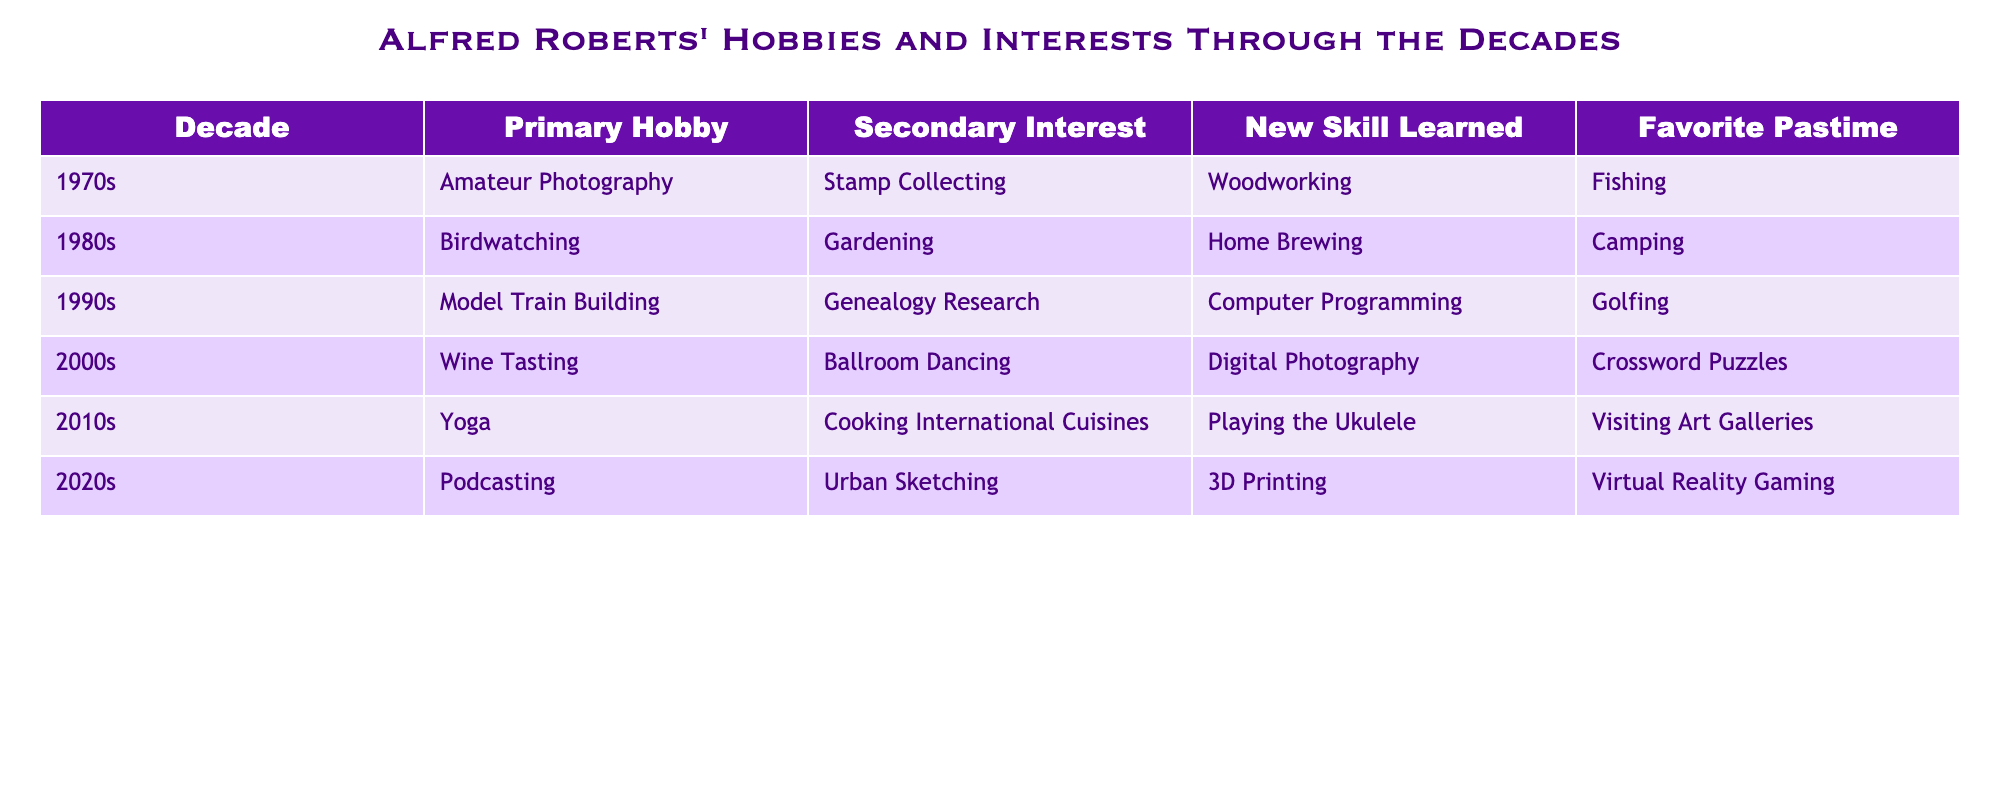What was Alfred's primary hobby in the 1990s? According to the table, the primary hobby listed for the 1990s is "Model Train Building."
Answer: Model Train Building Which decade did Alfred start practicing yoga? The table indicates that Alfred started practicing yoga in the 2010s, as it is listed as his primary hobby for that decade.
Answer: 2010s Did Alfred have any hobbies related to cooking in the 2000s? In the table, the primary hobby in the 2000s is "Wine Tasting" and the secondary interest is "Ballroom Dancing." There are no direct mentions of cooking-related hobbies in that decade.
Answer: No What is the difference in the number of new skills learned between the 1980s and the 2020s? The skills learned in the 1980s are "Home Brewing," and in the 2020s, it's "3D Printing." Since both decades have one new skill learned, the difference in the number is 1 - 1 = 0.
Answer: 0 What was Alfred’s favorite pastime throughout the decades listed? By reviewing the table, Alfred's favorite pastimes varied in each decade, with no repetitions across the decades. Each is unique to its respective decade: Fishing, Camping, Golfing, Crossword Puzzles, Visiting Art Galleries, and Virtual Reality Gaming.
Answer: Unique to each decade Which primary hobby appeared most recently in the table? According to the table, "Podcasting" appears as the primary hobby for the 2020s, making it the most recent primary hobby listed.
Answer: Podcasting In which decade did Alfred engage in the highest variety of interests (hobby and interest combined)? The 2010s show a good variety of activities with "Yoga" as the primary hobby and "Cooking International Cuisines" as the secondary interest. However, all decades have two interests listed, making them similar in that regard. Therefore, it could be said that all decades maintain a similar variety.
Answer: Similar in variety What skill did Alfred learn that involved technology? Looking through the table, "Computer Programming" in the 1990s and "3D Printing" in the 2020s both involve technology. Therefore, the skills learned related to technology are both of those.
Answer: Computer Programming and 3D Printing Was gardening Alfred's primary hobby or secondary interest? The table lists "Gardening" as a secondary interest in the 1980s, indicating it was not his primary hobby.
Answer: Secondary interest Which decade had a focus on creative hobbies, including dancing and photography? The 2000s emphasized creative hobbies with "Ballroom Dancing" as a secondary interest and "Digital Photography" as a new skill learned, both being artistic in nature.
Answer: 2000s 